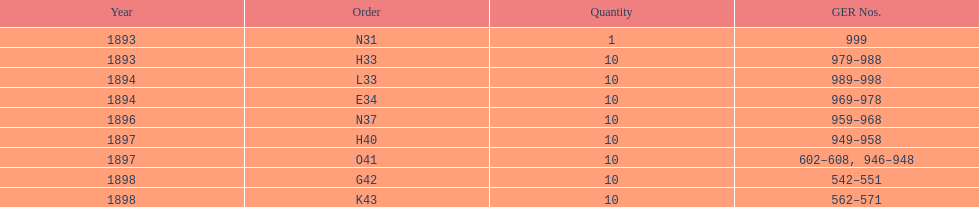Which year had a higher number of ger events, 1898 or 1893? 1898. 